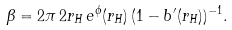<formula> <loc_0><loc_0><loc_500><loc_500>\beta = 2 \pi \, 2 r _ { H } \, e ^ { \phi } ( r _ { H } ) \, ( 1 - b ^ { \prime } ( r _ { H } ) ) ^ { - 1 } .</formula> 